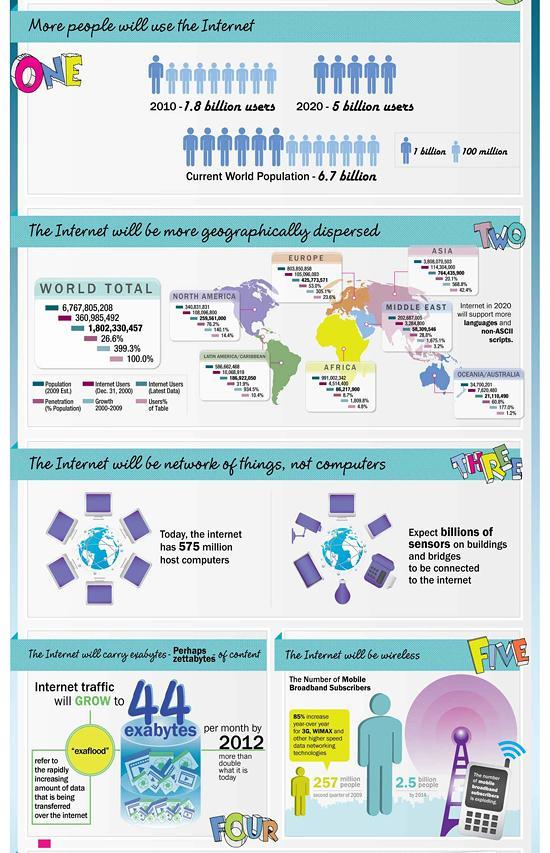By how much has the number of internet users increased in 2020, when compared to 2010 (billions)?
Answer the question with a short phrase. 3.2 How many points on the Internet are mentioned here? 5 At present how many host computers are there on the internet? 575 million What is the last point mentioned about the internet? The Internet will be wireless From the current world population how many  people do not use internet (billions)? 1.7 